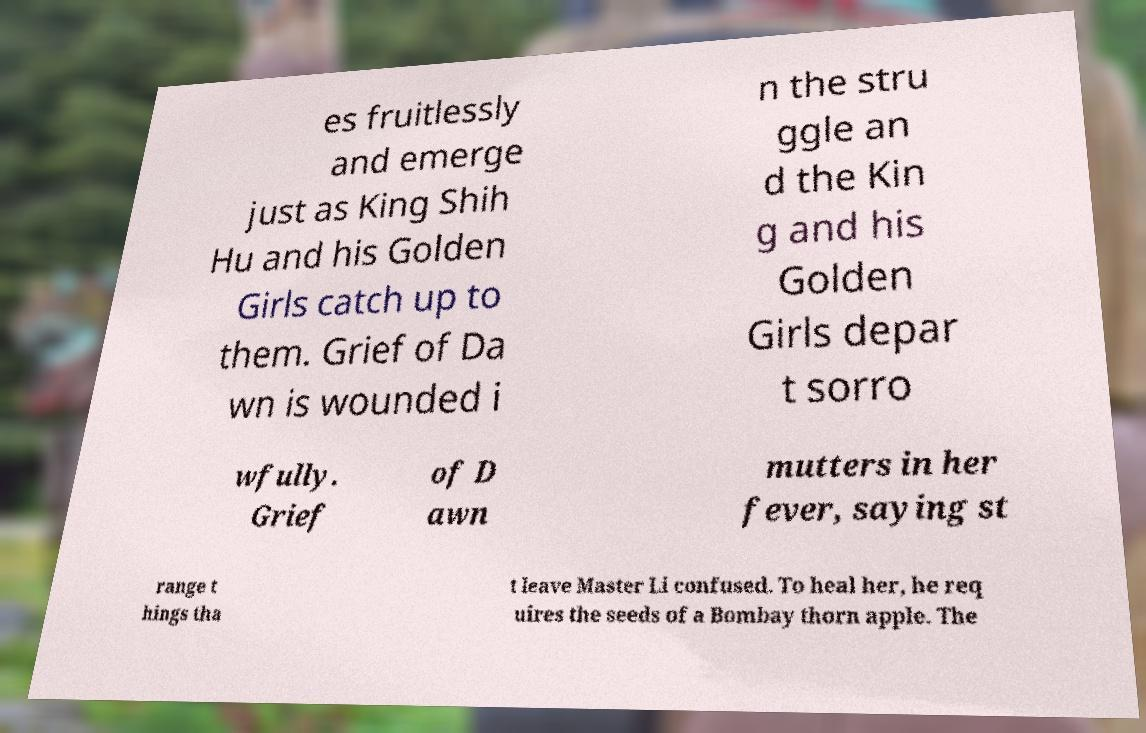Please identify and transcribe the text found in this image. es fruitlessly and emerge just as King Shih Hu and his Golden Girls catch up to them. Grief of Da wn is wounded i n the stru ggle an d the Kin g and his Golden Girls depar t sorro wfully. Grief of D awn mutters in her fever, saying st range t hings tha t leave Master Li confused. To heal her, he req uires the seeds of a Bombay thorn apple. The 